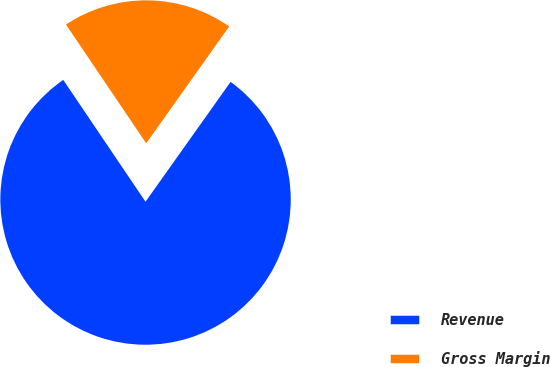<chart> <loc_0><loc_0><loc_500><loc_500><pie_chart><fcel>Revenue<fcel>Gross Margin<nl><fcel>80.72%<fcel>19.28%<nl></chart> 